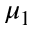Convert formula to latex. <formula><loc_0><loc_0><loc_500><loc_500>\mu _ { 1 }</formula> 